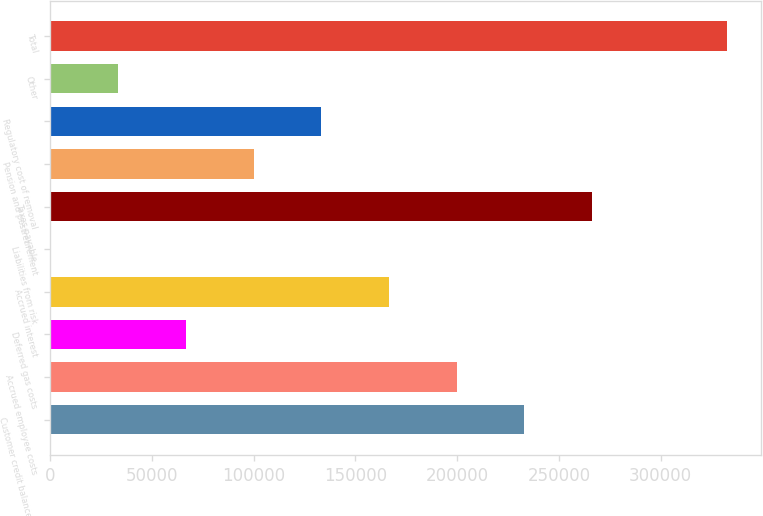Convert chart to OTSL. <chart><loc_0><loc_0><loc_500><loc_500><bar_chart><fcel>Customer credit balances and<fcel>Accrued employee costs<fcel>Deferred gas costs<fcel>Accrued interest<fcel>Liabilities from risk<fcel>Taxes payable<fcel>Pension and postretirement<fcel>Regulatory cost of removal<fcel>Other<fcel>Total<nl><fcel>232950<fcel>199718<fcel>66787.2<fcel>166485<fcel>322<fcel>266183<fcel>100020<fcel>133252<fcel>33554.6<fcel>332648<nl></chart> 